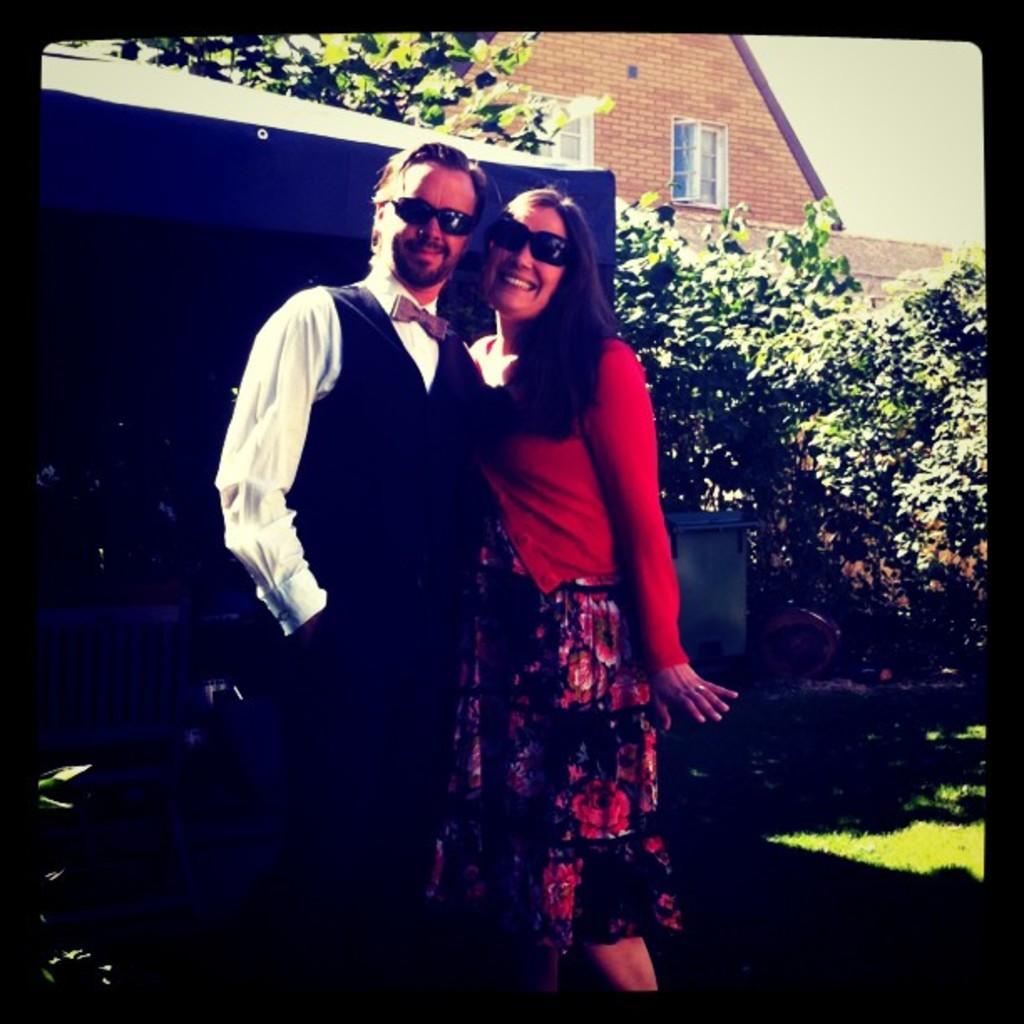Describe this image in one or two sentences. This image is an edited image. This image is taken outdoors. In the background there is a house. There are many trees. On the right side of the image there is a ground with grass on it. In the middle of the image a man and a woman are standing on the ground and they are with smiling faces. 